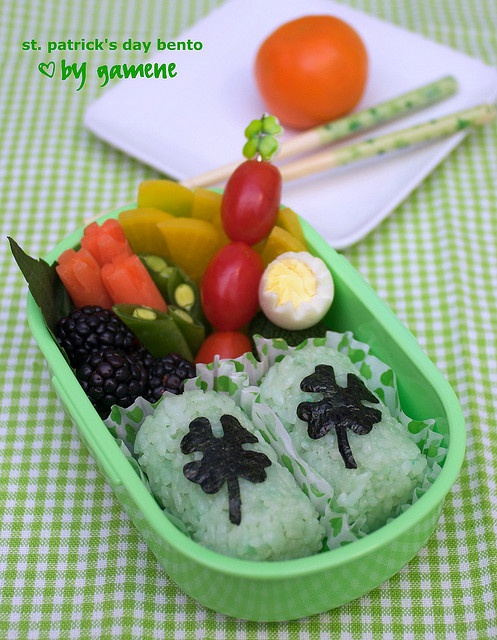Describe the objects in this image and their specific colors. I can see bowl in lightgreen, green, darkgray, and black tones, orange in lightgreen, red, salmon, brown, and lavender tones, and carrot in lightgreen, red, and brown tones in this image. 